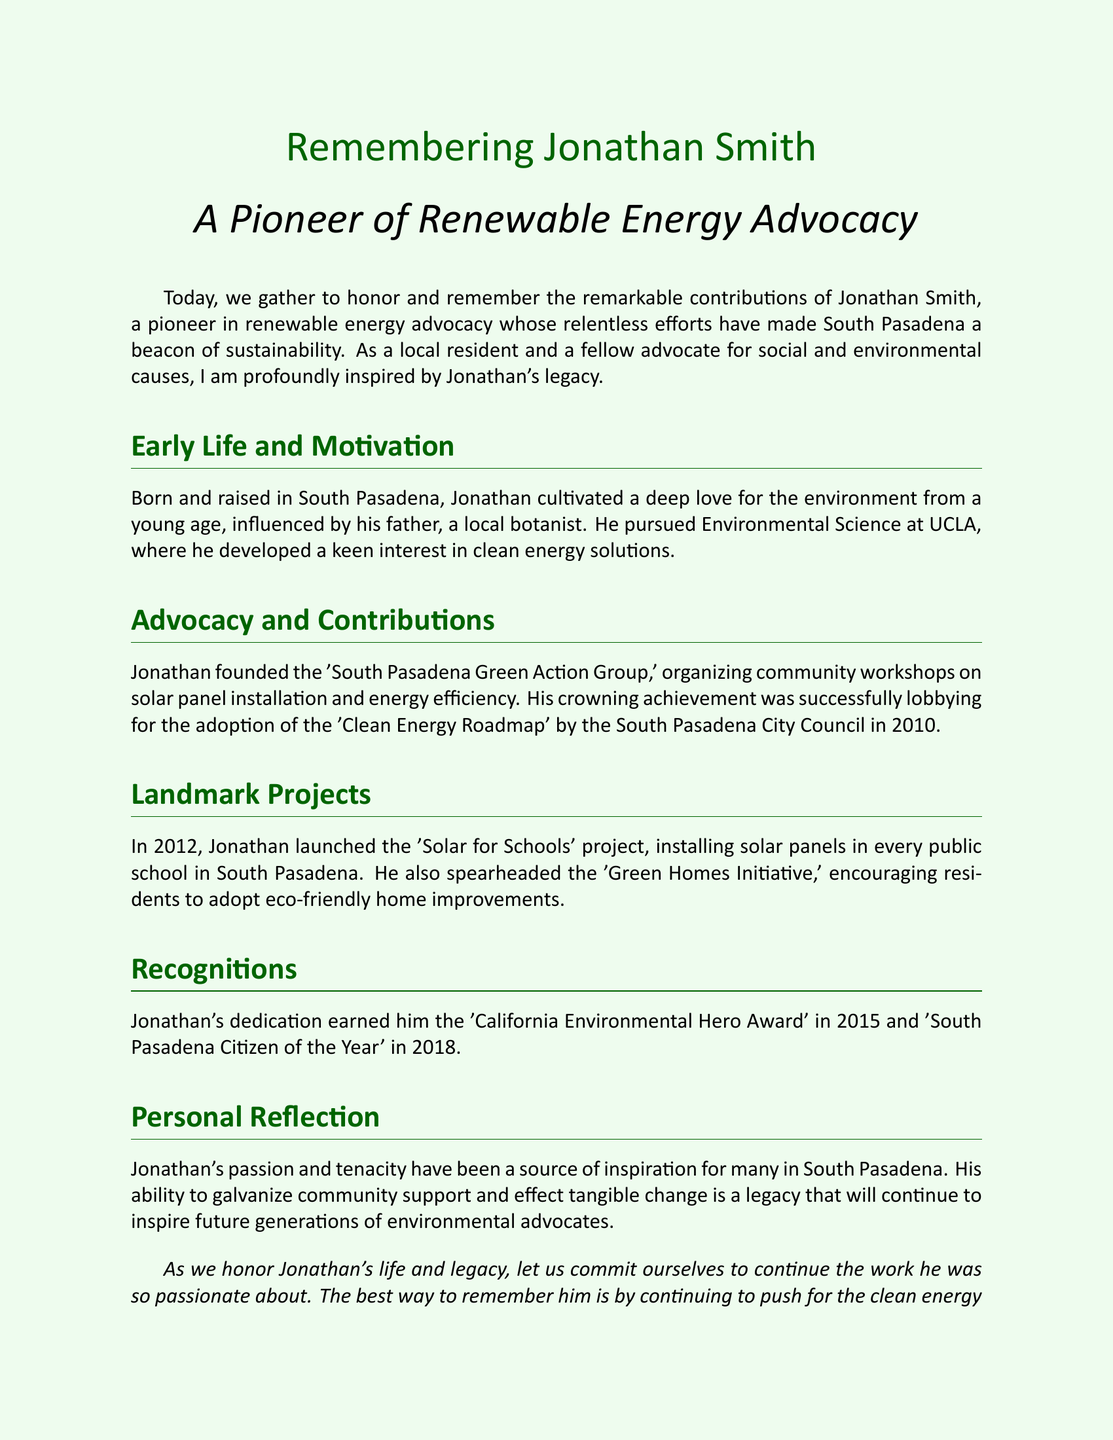What was the name of the advocacy group Jonathan founded? The document states that Jonathan founded the 'South Pasadena Green Action Group'.
Answer: South Pasadena Green Action Group In what year was the 'Clean Energy Roadmap' adopted by the City Council? The document mentions that the 'Clean Energy Roadmap' was adopted in 2010.
Answer: 2010 What project did Jonathan launch in 2012? The eulogy refers to the 'Solar for Schools' project launched in 2012.
Answer: Solar for Schools Which award did Jonathan receive in 2015? According to the document, Jonathan earned the 'California Environmental Hero Award' in 2015.
Answer: California Environmental Hero Award How many landmark projects are mentioned in the document? The text specifically highlights two landmark projects: 'Solar for Schools' and 'Green Homes Initiative'.
Answer: 2 What was the main focus of Jonathan's workshops? The document states that the workshops focused on solar panel installation and energy efficiency.
Answer: Solar panel installation and energy efficiency What is a key element of Jonathan's legacy? His ability to galvanize community support and effect tangible change is cited as a key element of his legacy.
Answer: Galvanizing community support What year did Jonathan win 'South Pasadena Citizen of the Year'? The eulogy mentions that he received this honor in 2018.
Answer: 2018 What was Jonathan's field of study at UCLA? The document notes that he pursued Environmental Science at UCLA.
Answer: Environmental Science 